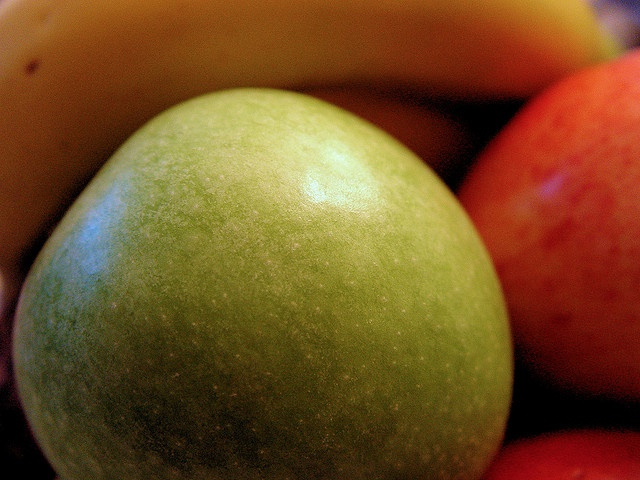Describe the objects in this image and their specific colors. I can see apple in salmon, olive, and black tones, banana in salmon, maroon, and brown tones, apple in salmon, brown, maroon, red, and black tones, and apple in maroon, brown, and salmon tones in this image. 